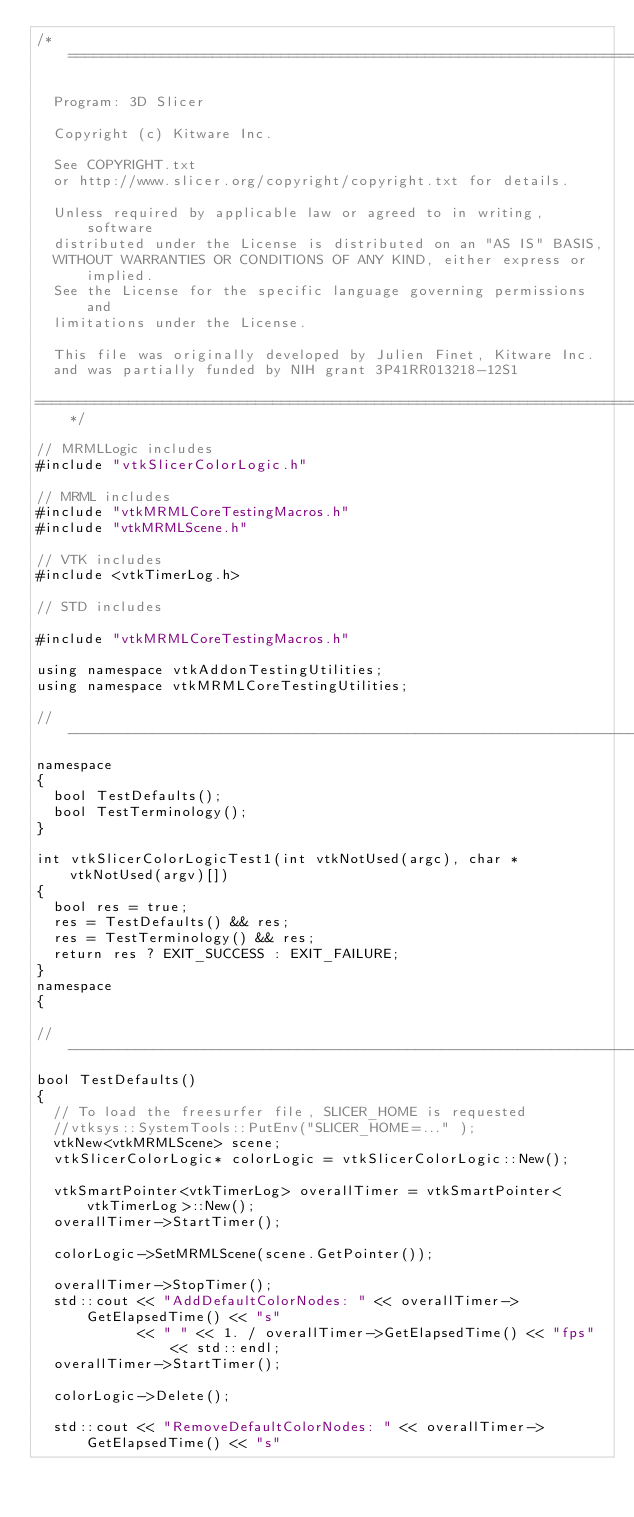<code> <loc_0><loc_0><loc_500><loc_500><_C++_>/*==============================================================================

  Program: 3D Slicer

  Copyright (c) Kitware Inc.

  See COPYRIGHT.txt
  or http://www.slicer.org/copyright/copyright.txt for details.

  Unless required by applicable law or agreed to in writing, software
  distributed under the License is distributed on an "AS IS" BASIS,
  WITHOUT WARRANTIES OR CONDITIONS OF ANY KIND, either express or implied.
  See the License for the specific language governing permissions and
  limitations under the License.

  This file was originally developed by Julien Finet, Kitware Inc.
  and was partially funded by NIH grant 3P41RR013218-12S1

==============================================================================*/

// MRMLLogic includes
#include "vtkSlicerColorLogic.h"

// MRML includes
#include "vtkMRMLCoreTestingMacros.h"
#include "vtkMRMLScene.h"

// VTK includes
#include <vtkTimerLog.h>

// STD includes

#include "vtkMRMLCoreTestingMacros.h"

using namespace vtkAddonTestingUtilities;
using namespace vtkMRMLCoreTestingUtilities;

//----------------------------------------------------------------------------
namespace
{
  bool TestDefaults();
  bool TestTerminology();
}

int vtkSlicerColorLogicTest1(int vtkNotUsed(argc), char * vtkNotUsed(argv)[])
{
  bool res = true;
  res = TestDefaults() && res;
  res = TestTerminology() && res;
  return res ? EXIT_SUCCESS : EXIT_FAILURE;
}
namespace
{

//----------------------------------------------------------------------------
bool TestDefaults()
{
  // To load the freesurfer file, SLICER_HOME is requested
  //vtksys::SystemTools::PutEnv("SLICER_HOME=..." );
  vtkNew<vtkMRMLScene> scene;
  vtkSlicerColorLogic* colorLogic = vtkSlicerColorLogic::New();

  vtkSmartPointer<vtkTimerLog> overallTimer = vtkSmartPointer<vtkTimerLog>::New();
  overallTimer->StartTimer();

  colorLogic->SetMRMLScene(scene.GetPointer());

  overallTimer->StopTimer();
  std::cout << "AddDefaultColorNodes: " << overallTimer->GetElapsedTime() << "s"
            << " " << 1. / overallTimer->GetElapsedTime() << "fps" << std::endl;
  overallTimer->StartTimer();

  colorLogic->Delete();

  std::cout << "RemoveDefaultColorNodes: " << overallTimer->GetElapsedTime() << "s"</code> 